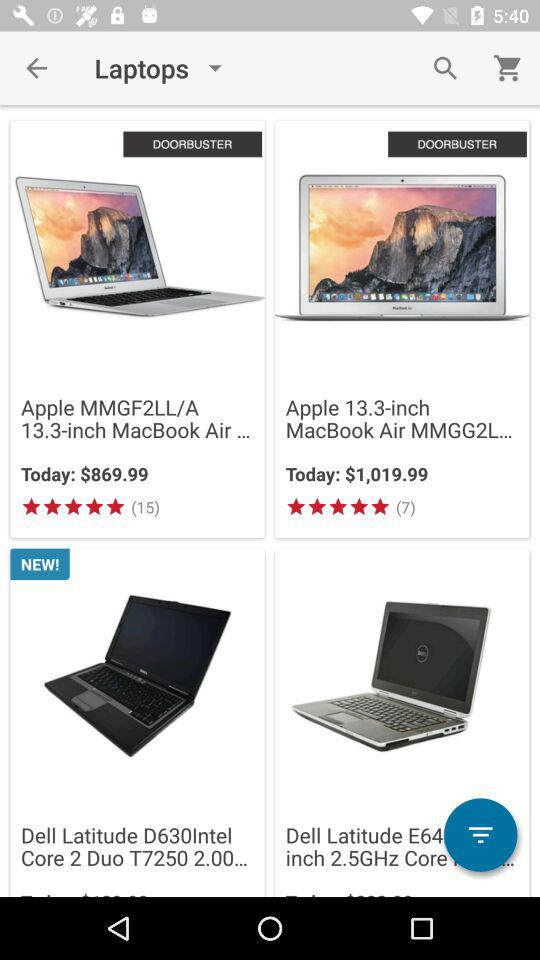What is the rating of the "Apple 13.3-inch MacBook Air MMGG2L"? The rating of the "Apple 13.3-inch MacBook Air MMGG2L" is 5 stars. 